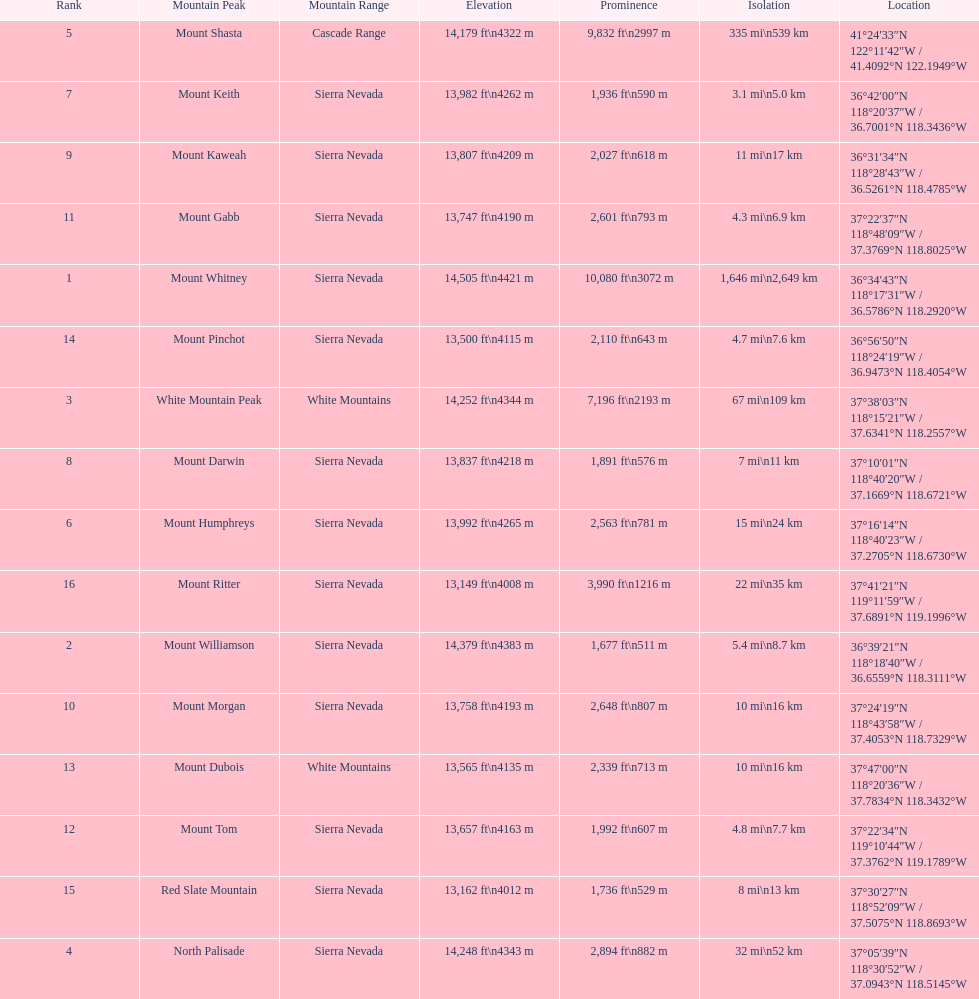Would you be able to parse every entry in this table? {'header': ['Rank', 'Mountain Peak', 'Mountain Range', 'Elevation', 'Prominence', 'Isolation', 'Location'], 'rows': [['5', 'Mount Shasta', 'Cascade Range', '14,179\xa0ft\\n4322\xa0m', '9,832\xa0ft\\n2997\xa0m', '335\xa0mi\\n539\xa0km', '41°24′33″N 122°11′42″W\ufeff / \ufeff41.4092°N 122.1949°W'], ['7', 'Mount Keith', 'Sierra Nevada', '13,982\xa0ft\\n4262\xa0m', '1,936\xa0ft\\n590\xa0m', '3.1\xa0mi\\n5.0\xa0km', '36°42′00″N 118°20′37″W\ufeff / \ufeff36.7001°N 118.3436°W'], ['9', 'Mount Kaweah', 'Sierra Nevada', '13,807\xa0ft\\n4209\xa0m', '2,027\xa0ft\\n618\xa0m', '11\xa0mi\\n17\xa0km', '36°31′34″N 118°28′43″W\ufeff / \ufeff36.5261°N 118.4785°W'], ['11', 'Mount Gabb', 'Sierra Nevada', '13,747\xa0ft\\n4190\xa0m', '2,601\xa0ft\\n793\xa0m', '4.3\xa0mi\\n6.9\xa0km', '37°22′37″N 118°48′09″W\ufeff / \ufeff37.3769°N 118.8025°W'], ['1', 'Mount Whitney', 'Sierra Nevada', '14,505\xa0ft\\n4421\xa0m', '10,080\xa0ft\\n3072\xa0m', '1,646\xa0mi\\n2,649\xa0km', '36°34′43″N 118°17′31″W\ufeff / \ufeff36.5786°N 118.2920°W'], ['14', 'Mount Pinchot', 'Sierra Nevada', '13,500\xa0ft\\n4115\xa0m', '2,110\xa0ft\\n643\xa0m', '4.7\xa0mi\\n7.6\xa0km', '36°56′50″N 118°24′19″W\ufeff / \ufeff36.9473°N 118.4054°W'], ['3', 'White Mountain Peak', 'White Mountains', '14,252\xa0ft\\n4344\xa0m', '7,196\xa0ft\\n2193\xa0m', '67\xa0mi\\n109\xa0km', '37°38′03″N 118°15′21″W\ufeff / \ufeff37.6341°N 118.2557°W'], ['8', 'Mount Darwin', 'Sierra Nevada', '13,837\xa0ft\\n4218\xa0m', '1,891\xa0ft\\n576\xa0m', '7\xa0mi\\n11\xa0km', '37°10′01″N 118°40′20″W\ufeff / \ufeff37.1669°N 118.6721°W'], ['6', 'Mount Humphreys', 'Sierra Nevada', '13,992\xa0ft\\n4265\xa0m', '2,563\xa0ft\\n781\xa0m', '15\xa0mi\\n24\xa0km', '37°16′14″N 118°40′23″W\ufeff / \ufeff37.2705°N 118.6730°W'], ['16', 'Mount Ritter', 'Sierra Nevada', '13,149\xa0ft\\n4008\xa0m', '3,990\xa0ft\\n1216\xa0m', '22\xa0mi\\n35\xa0km', '37°41′21″N 119°11′59″W\ufeff / \ufeff37.6891°N 119.1996°W'], ['2', 'Mount Williamson', 'Sierra Nevada', '14,379\xa0ft\\n4383\xa0m', '1,677\xa0ft\\n511\xa0m', '5.4\xa0mi\\n8.7\xa0km', '36°39′21″N 118°18′40″W\ufeff / \ufeff36.6559°N 118.3111°W'], ['10', 'Mount Morgan', 'Sierra Nevada', '13,758\xa0ft\\n4193\xa0m', '2,648\xa0ft\\n807\xa0m', '10\xa0mi\\n16\xa0km', '37°24′19″N 118°43′58″W\ufeff / \ufeff37.4053°N 118.7329°W'], ['13', 'Mount Dubois', 'White Mountains', '13,565\xa0ft\\n4135\xa0m', '2,339\xa0ft\\n713\xa0m', '10\xa0mi\\n16\xa0km', '37°47′00″N 118°20′36″W\ufeff / \ufeff37.7834°N 118.3432°W'], ['12', 'Mount Tom', 'Sierra Nevada', '13,657\xa0ft\\n4163\xa0m', '1,992\xa0ft\\n607\xa0m', '4.8\xa0mi\\n7.7\xa0km', '37°22′34″N 119°10′44″W\ufeff / \ufeff37.3762°N 119.1789°W'], ['15', 'Red Slate Mountain', 'Sierra Nevada', '13,162\xa0ft\\n4012\xa0m', '1,736\xa0ft\\n529\xa0m', '8\xa0mi\\n13\xa0km', '37°30′27″N 118°52′09″W\ufeff / \ufeff37.5075°N 118.8693°W'], ['4', 'North Palisade', 'Sierra Nevada', '14,248\xa0ft\\n4343\xa0m', '2,894\xa0ft\\n882\xa0m', '32\xa0mi\\n52\xa0km', '37°05′39″N 118°30′52″W\ufeff / \ufeff37.0943°N 118.5145°W']]} Which mountain peak has the most isolation? Mount Whitney. 